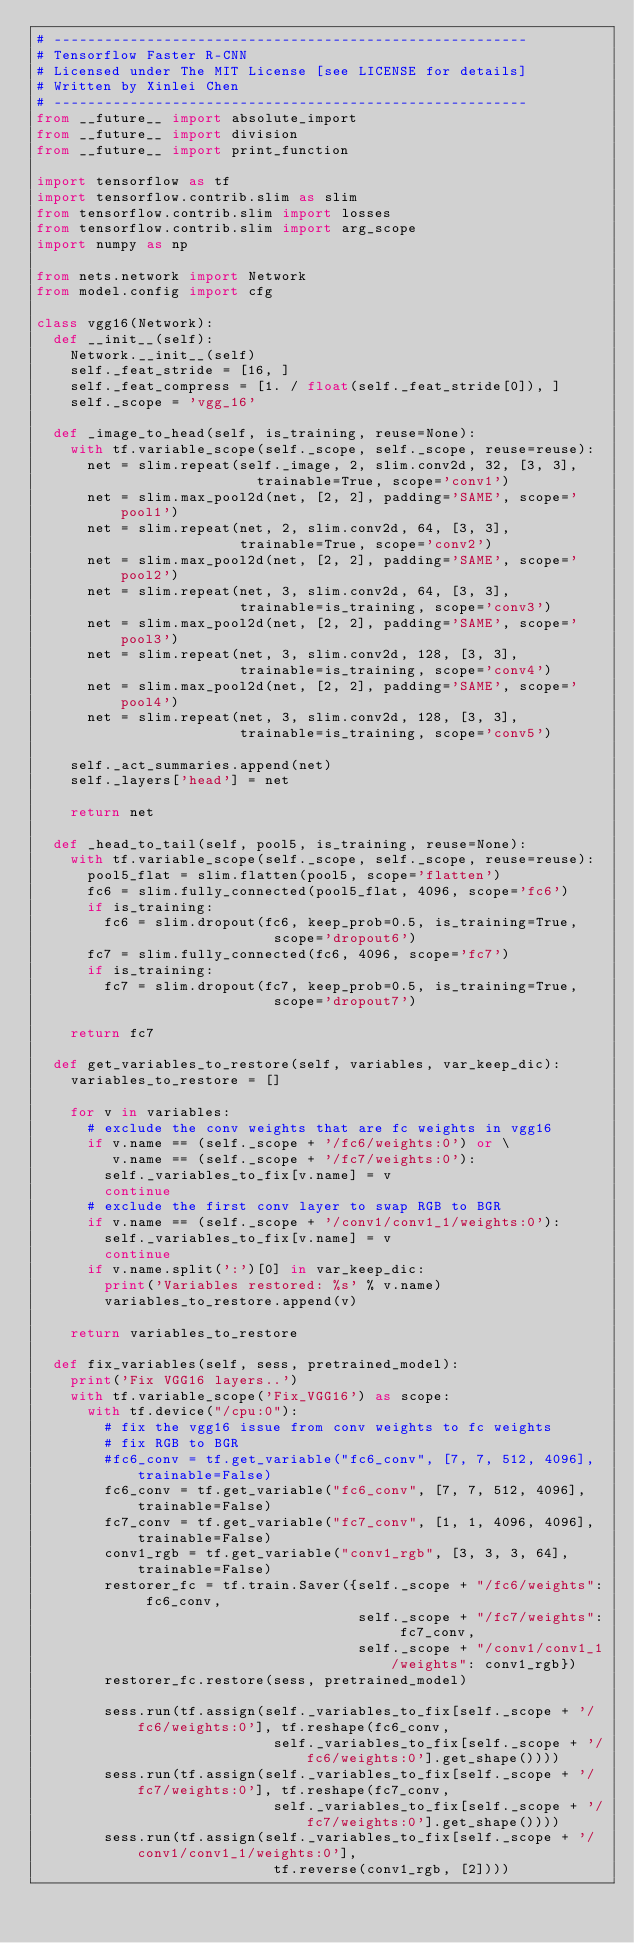<code> <loc_0><loc_0><loc_500><loc_500><_Python_># --------------------------------------------------------
# Tensorflow Faster R-CNN
# Licensed under The MIT License [see LICENSE for details]
# Written by Xinlei Chen
# --------------------------------------------------------
from __future__ import absolute_import
from __future__ import division
from __future__ import print_function

import tensorflow as tf
import tensorflow.contrib.slim as slim
from tensorflow.contrib.slim import losses
from tensorflow.contrib.slim import arg_scope
import numpy as np

from nets.network import Network
from model.config import cfg

class vgg16(Network):
  def __init__(self):
    Network.__init__(self)
    self._feat_stride = [16, ]
    self._feat_compress = [1. / float(self._feat_stride[0]), ]
    self._scope = 'vgg_16'

  def _image_to_head(self, is_training, reuse=None):
    with tf.variable_scope(self._scope, self._scope, reuse=reuse):
      net = slim.repeat(self._image, 2, slim.conv2d, 32, [3, 3],
                          trainable=True, scope='conv1')
      net = slim.max_pool2d(net, [2, 2], padding='SAME', scope='pool1')
      net = slim.repeat(net, 2, slim.conv2d, 64, [3, 3],
                        trainable=True, scope='conv2')
      net = slim.max_pool2d(net, [2, 2], padding='SAME', scope='pool2')
      net = slim.repeat(net, 3, slim.conv2d, 64, [3, 3],
                        trainable=is_training, scope='conv3')
      net = slim.max_pool2d(net, [2, 2], padding='SAME', scope='pool3')
      net = slim.repeat(net, 3, slim.conv2d, 128, [3, 3],
                        trainable=is_training, scope='conv4')
      net = slim.max_pool2d(net, [2, 2], padding='SAME', scope='pool4')
      net = slim.repeat(net, 3, slim.conv2d, 128, [3, 3],
                        trainable=is_training, scope='conv5')

    self._act_summaries.append(net)
    self._layers['head'] = net
    
    return net

  def _head_to_tail(self, pool5, is_training, reuse=None):
    with tf.variable_scope(self._scope, self._scope, reuse=reuse):
      pool5_flat = slim.flatten(pool5, scope='flatten')
      fc6 = slim.fully_connected(pool5_flat, 4096, scope='fc6')
      if is_training:
        fc6 = slim.dropout(fc6, keep_prob=0.5, is_training=True, 
                            scope='dropout6')
      fc7 = slim.fully_connected(fc6, 4096, scope='fc7')
      if is_training:
        fc7 = slim.dropout(fc7, keep_prob=0.5, is_training=True, 
                            scope='dropout7')

    return fc7

  def get_variables_to_restore(self, variables, var_keep_dic):
    variables_to_restore = []

    for v in variables:
      # exclude the conv weights that are fc weights in vgg16
      if v.name == (self._scope + '/fc6/weights:0') or \
         v.name == (self._scope + '/fc7/weights:0'):
        self._variables_to_fix[v.name] = v
        continue
      # exclude the first conv layer to swap RGB to BGR
      if v.name == (self._scope + '/conv1/conv1_1/weights:0'):
        self._variables_to_fix[v.name] = v
        continue
      if v.name.split(':')[0] in var_keep_dic:
        print('Variables restored: %s' % v.name)
        variables_to_restore.append(v)

    return variables_to_restore

  def fix_variables(self, sess, pretrained_model):
    print('Fix VGG16 layers..')
    with tf.variable_scope('Fix_VGG16') as scope:
      with tf.device("/cpu:0"):
        # fix the vgg16 issue from conv weights to fc weights
        # fix RGB to BGR
        #fc6_conv = tf.get_variable("fc6_conv", [7, 7, 512, 4096], trainable=False)
        fc6_conv = tf.get_variable("fc6_conv", [7, 7, 512, 4096], trainable=False)
        fc7_conv = tf.get_variable("fc7_conv", [1, 1, 4096, 4096], trainable=False)
        conv1_rgb = tf.get_variable("conv1_rgb", [3, 3, 3, 64], trainable=False)
        restorer_fc = tf.train.Saver({self._scope + "/fc6/weights": fc6_conv, 
                                      self._scope + "/fc7/weights": fc7_conv,
                                      self._scope + "/conv1/conv1_1/weights": conv1_rgb})
        restorer_fc.restore(sess, pretrained_model)

        sess.run(tf.assign(self._variables_to_fix[self._scope + '/fc6/weights:0'], tf.reshape(fc6_conv, 
                            self._variables_to_fix[self._scope + '/fc6/weights:0'].get_shape())))
        sess.run(tf.assign(self._variables_to_fix[self._scope + '/fc7/weights:0'], tf.reshape(fc7_conv, 
                            self._variables_to_fix[self._scope + '/fc7/weights:0'].get_shape())))
        sess.run(tf.assign(self._variables_to_fix[self._scope + '/conv1/conv1_1/weights:0'], 
                            tf.reverse(conv1_rgb, [2])))
</code> 